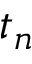Convert formula to latex. <formula><loc_0><loc_0><loc_500><loc_500>t _ { n }</formula> 